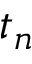Convert formula to latex. <formula><loc_0><loc_0><loc_500><loc_500>t _ { n }</formula> 